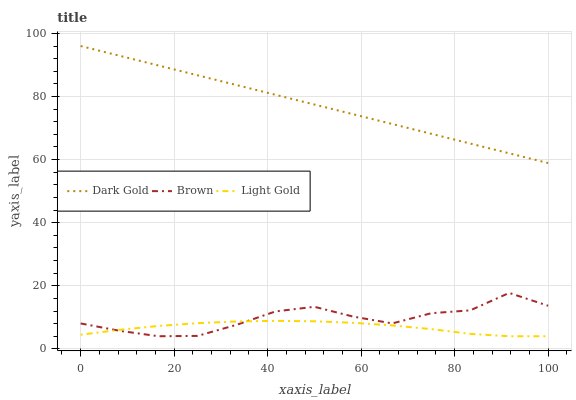Does Light Gold have the minimum area under the curve?
Answer yes or no. Yes. Does Dark Gold have the maximum area under the curve?
Answer yes or no. Yes. Does Dark Gold have the minimum area under the curve?
Answer yes or no. No. Does Light Gold have the maximum area under the curve?
Answer yes or no. No. Is Dark Gold the smoothest?
Answer yes or no. Yes. Is Brown the roughest?
Answer yes or no. Yes. Is Light Gold the smoothest?
Answer yes or no. No. Is Light Gold the roughest?
Answer yes or no. No. Does Brown have the lowest value?
Answer yes or no. Yes. Does Dark Gold have the lowest value?
Answer yes or no. No. Does Dark Gold have the highest value?
Answer yes or no. Yes. Does Light Gold have the highest value?
Answer yes or no. No. Is Brown less than Dark Gold?
Answer yes or no. Yes. Is Dark Gold greater than Light Gold?
Answer yes or no. Yes. Does Brown intersect Light Gold?
Answer yes or no. Yes. Is Brown less than Light Gold?
Answer yes or no. No. Is Brown greater than Light Gold?
Answer yes or no. No. Does Brown intersect Dark Gold?
Answer yes or no. No. 